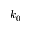Convert formula to latex. <formula><loc_0><loc_0><loc_500><loc_500>k _ { 0 }</formula> 